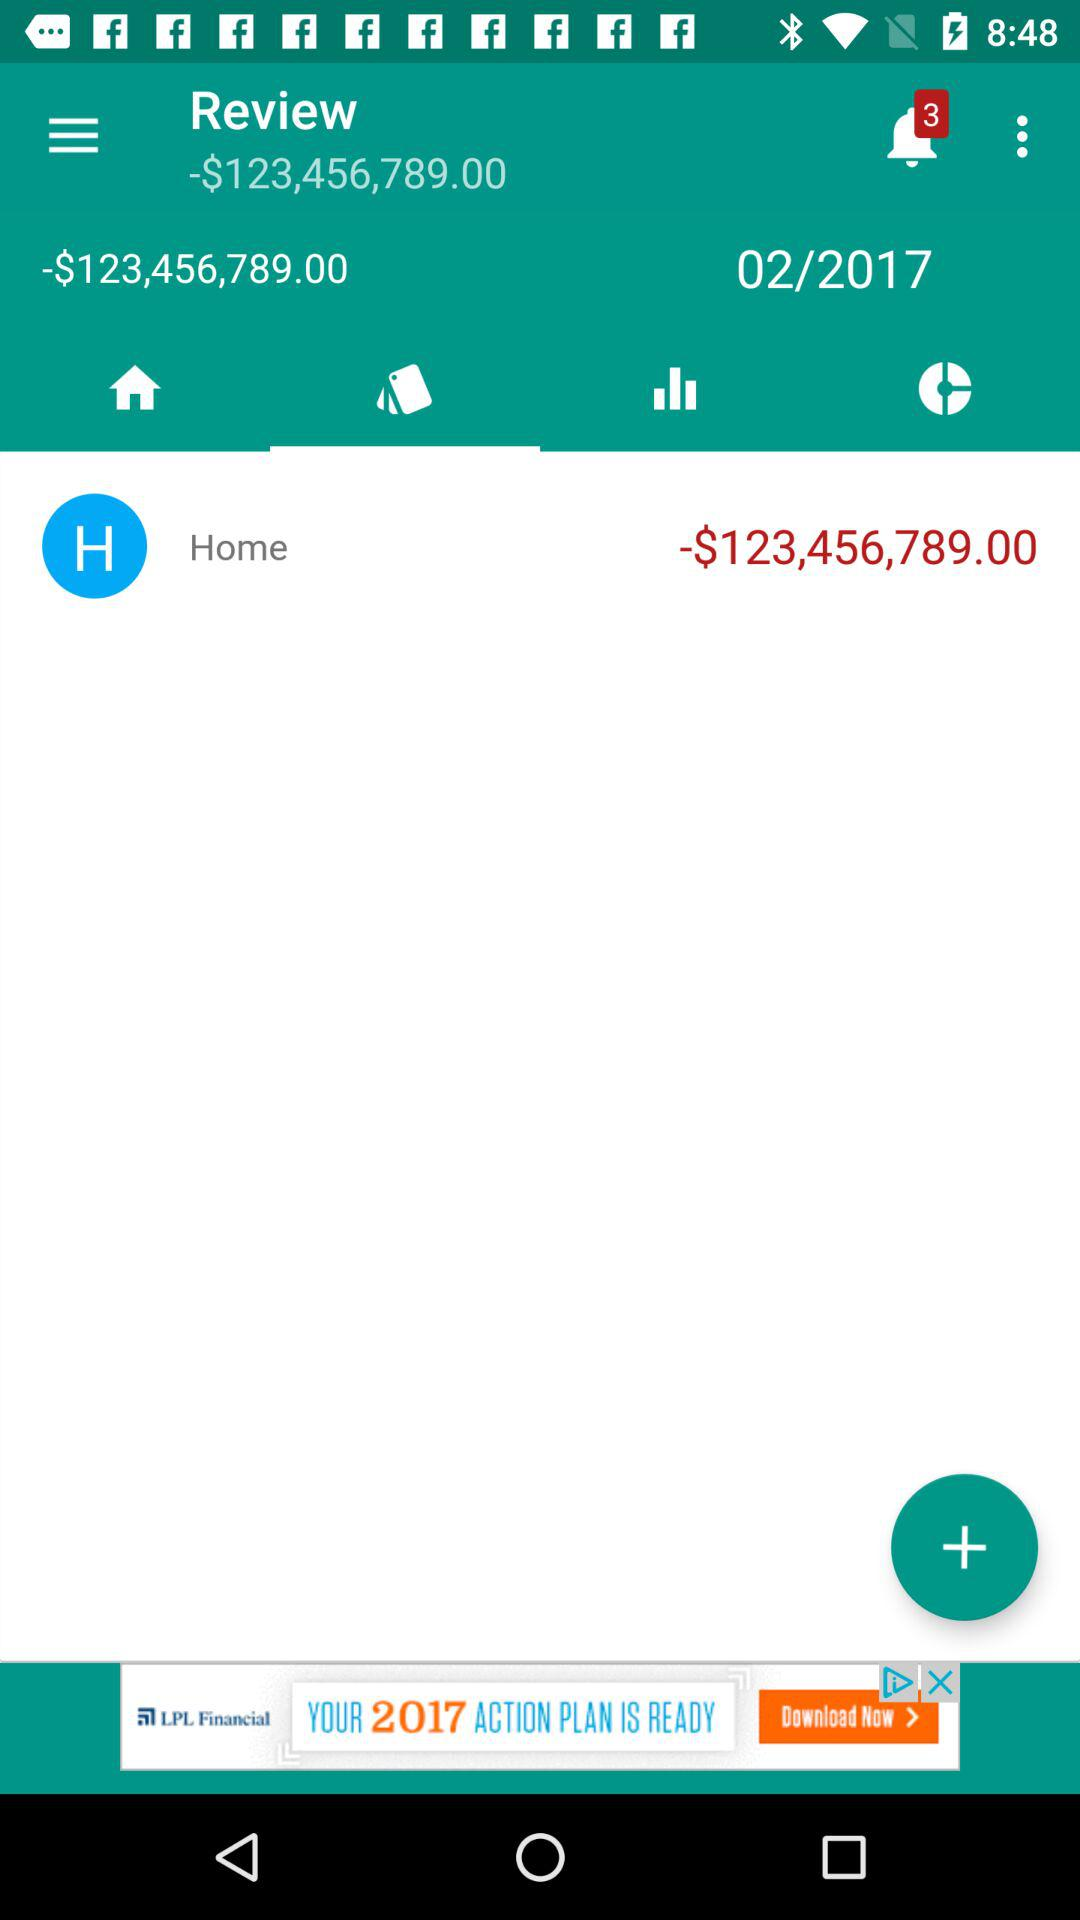What is the mentioned date? The mentioned date is 02/2017. 